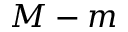<formula> <loc_0><loc_0><loc_500><loc_500>M - m</formula> 